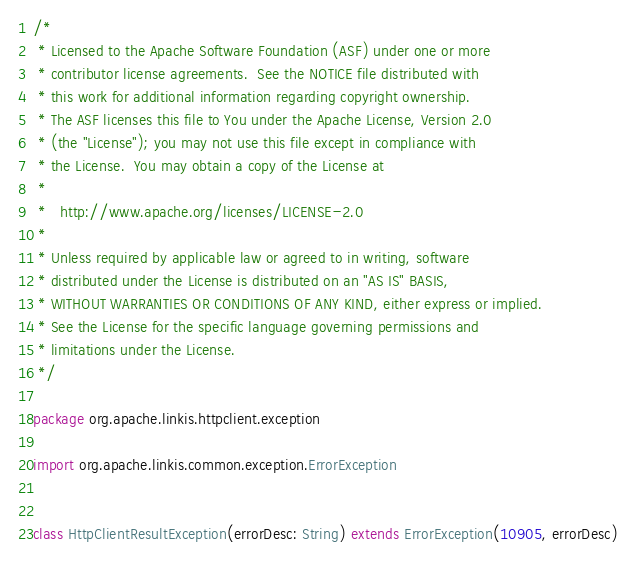<code> <loc_0><loc_0><loc_500><loc_500><_Scala_>/*
 * Licensed to the Apache Software Foundation (ASF) under one or more
 * contributor license agreements.  See the NOTICE file distributed with
 * this work for additional information regarding copyright ownership.
 * The ASF licenses this file to You under the Apache License, Version 2.0
 * (the "License"); you may not use this file except in compliance with
 * the License.  You may obtain a copy of the License at
 * 
 *   http://www.apache.org/licenses/LICENSE-2.0
 * 
 * Unless required by applicable law or agreed to in writing, software
 * distributed under the License is distributed on an "AS IS" BASIS,
 * WITHOUT WARRANTIES OR CONDITIONS OF ANY KIND, either express or implied.
 * See the License for the specific language governing permissions and
 * limitations under the License.
 */
 
package org.apache.linkis.httpclient.exception

import org.apache.linkis.common.exception.ErrorException


class HttpClientResultException(errorDesc: String) extends ErrorException(10905, errorDesc)</code> 